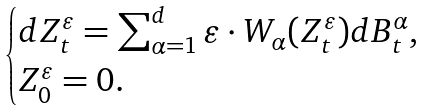<formula> <loc_0><loc_0><loc_500><loc_500>\begin{cases} d Z _ { t } ^ { \varepsilon } = \sum _ { \alpha = 1 } ^ { d } \varepsilon \cdot W _ { \alpha } ( Z _ { t } ^ { \varepsilon } ) d B _ { t } ^ { \alpha } , \\ Z _ { 0 } ^ { \varepsilon } = 0 . \end{cases}</formula> 